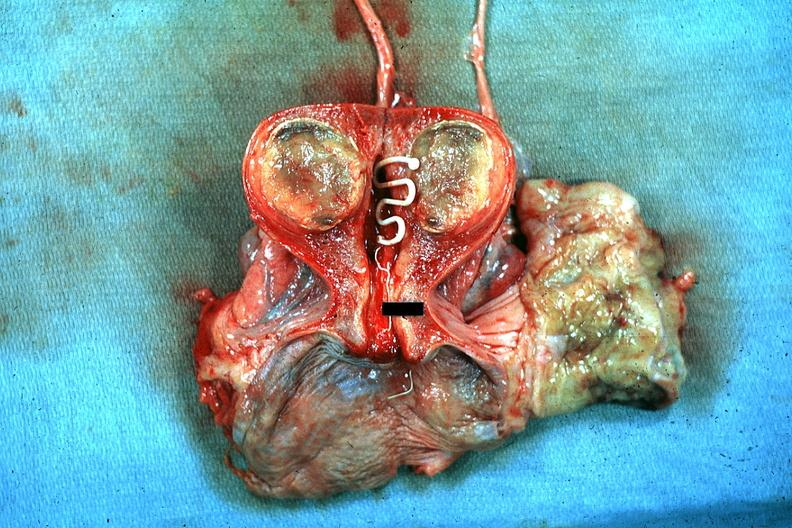s female reproductive present?
Answer the question using a single word or phrase. Yes 